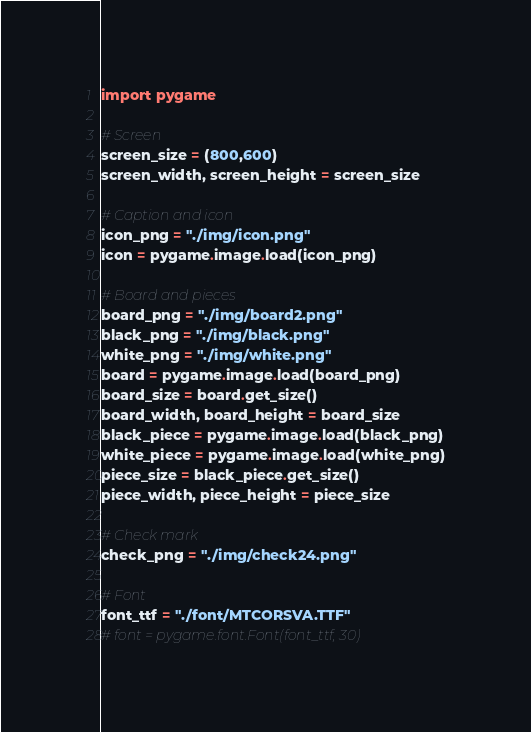Convert code to text. <code><loc_0><loc_0><loc_500><loc_500><_Python_>import pygame

# Screen
screen_size = (800,600)
screen_width, screen_height = screen_size

# Caption and icon
icon_png = "./img/icon.png"
icon = pygame.image.load(icon_png)

# Board and pieces
board_png = "./img/board2.png"
black_png = "./img/black.png"
white_png = "./img/white.png"
board = pygame.image.load(board_png)
board_size = board.get_size()
board_width, board_height = board_size
black_piece = pygame.image.load(black_png)
white_piece = pygame.image.load(white_png)
piece_size = black_piece.get_size()
piece_width, piece_height = piece_size

# Check mark
check_png = "./img/check24.png"

# Font
font_ttf = "./font/MTCORSVA.TTF"
# font = pygame.font.Font(font_ttf, 30)</code> 